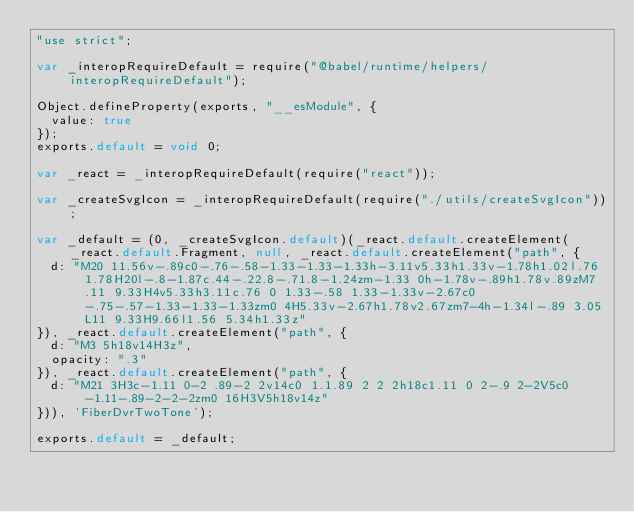<code> <loc_0><loc_0><loc_500><loc_500><_JavaScript_>"use strict";

var _interopRequireDefault = require("@babel/runtime/helpers/interopRequireDefault");

Object.defineProperty(exports, "__esModule", {
  value: true
});
exports.default = void 0;

var _react = _interopRequireDefault(require("react"));

var _createSvgIcon = _interopRequireDefault(require("./utils/createSvgIcon"));

var _default = (0, _createSvgIcon.default)(_react.default.createElement(_react.default.Fragment, null, _react.default.createElement("path", {
  d: "M20 11.56v-.89c0-.76-.58-1.33-1.33-1.33h-3.11v5.33h1.33v-1.78h1.02l.76 1.78H20l-.8-1.87c.44-.22.8-.71.8-1.24zm-1.33 0h-1.78v-.89h1.78v.89zM7.11 9.33H4v5.33h3.11c.76 0 1.33-.58 1.33-1.33v-2.67c0-.75-.57-1.33-1.33-1.33zm0 4H5.33v-2.67h1.78v2.67zm7-4h-1.34l-.89 3.05L11 9.33H9.66l1.56 5.34h1.33z"
}), _react.default.createElement("path", {
  d: "M3 5h18v14H3z",
  opacity: ".3"
}), _react.default.createElement("path", {
  d: "M21 3H3c-1.11 0-2 .89-2 2v14c0 1.1.89 2 2 2h18c1.11 0 2-.9 2-2V5c0-1.11-.89-2-2-2zm0 16H3V5h18v14z"
})), 'FiberDvrTwoTone');

exports.default = _default;</code> 